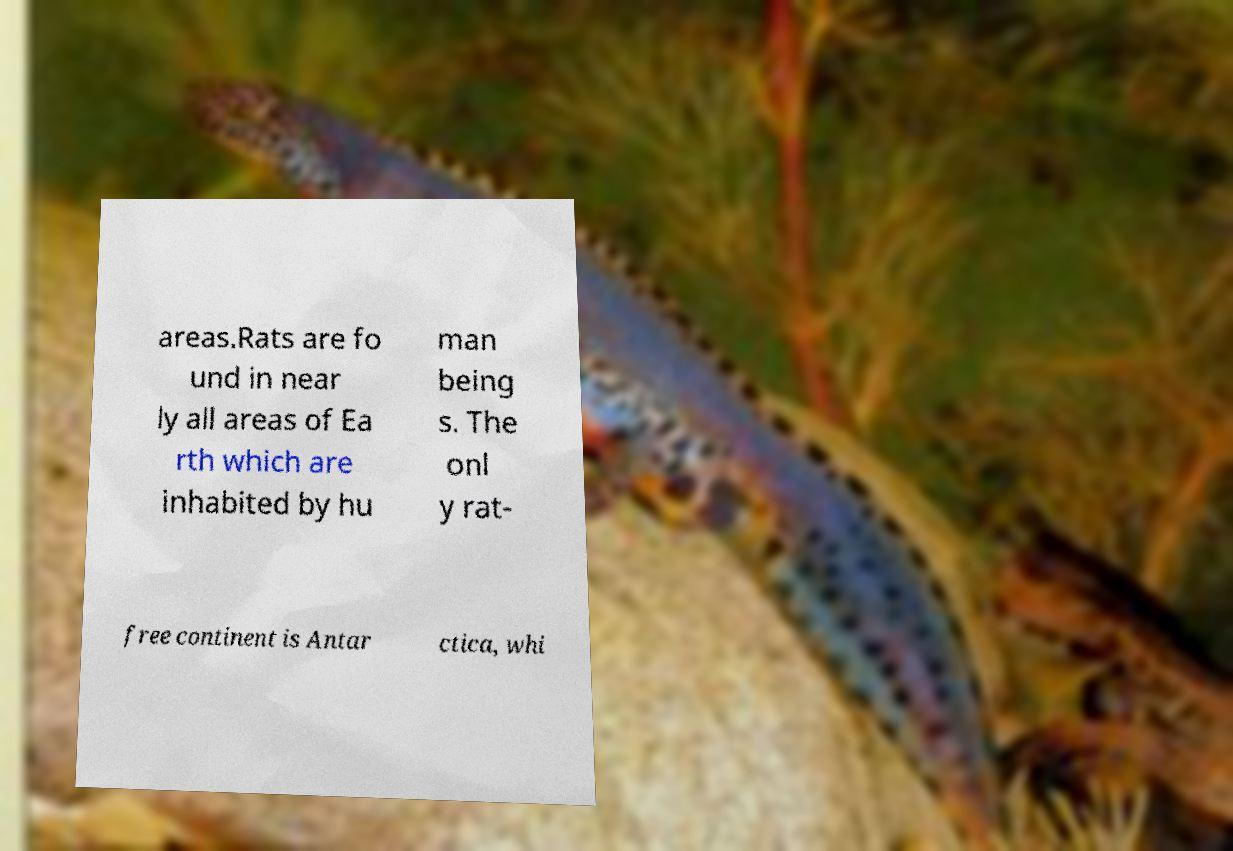Could you extract and type out the text from this image? areas.Rats are fo und in near ly all areas of Ea rth which are inhabited by hu man being s. The onl y rat- free continent is Antar ctica, whi 